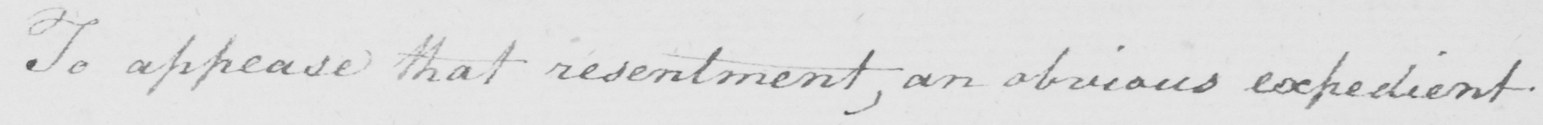Please transcribe the handwritten text in this image. To appease that resentment  , an obvious expedient 